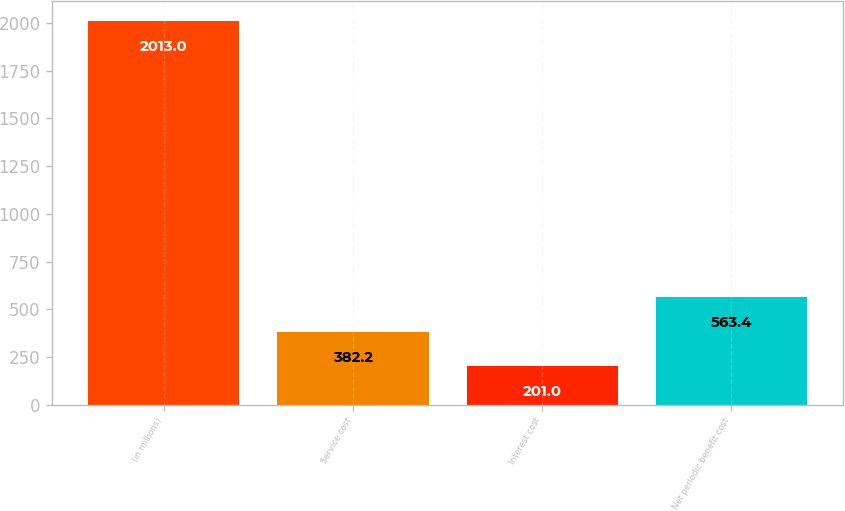Convert chart. <chart><loc_0><loc_0><loc_500><loc_500><bar_chart><fcel>(in millions)<fcel>Service cost<fcel>Interest cost<fcel>Net periodic benefit cost<nl><fcel>2013<fcel>382.2<fcel>201<fcel>563.4<nl></chart> 